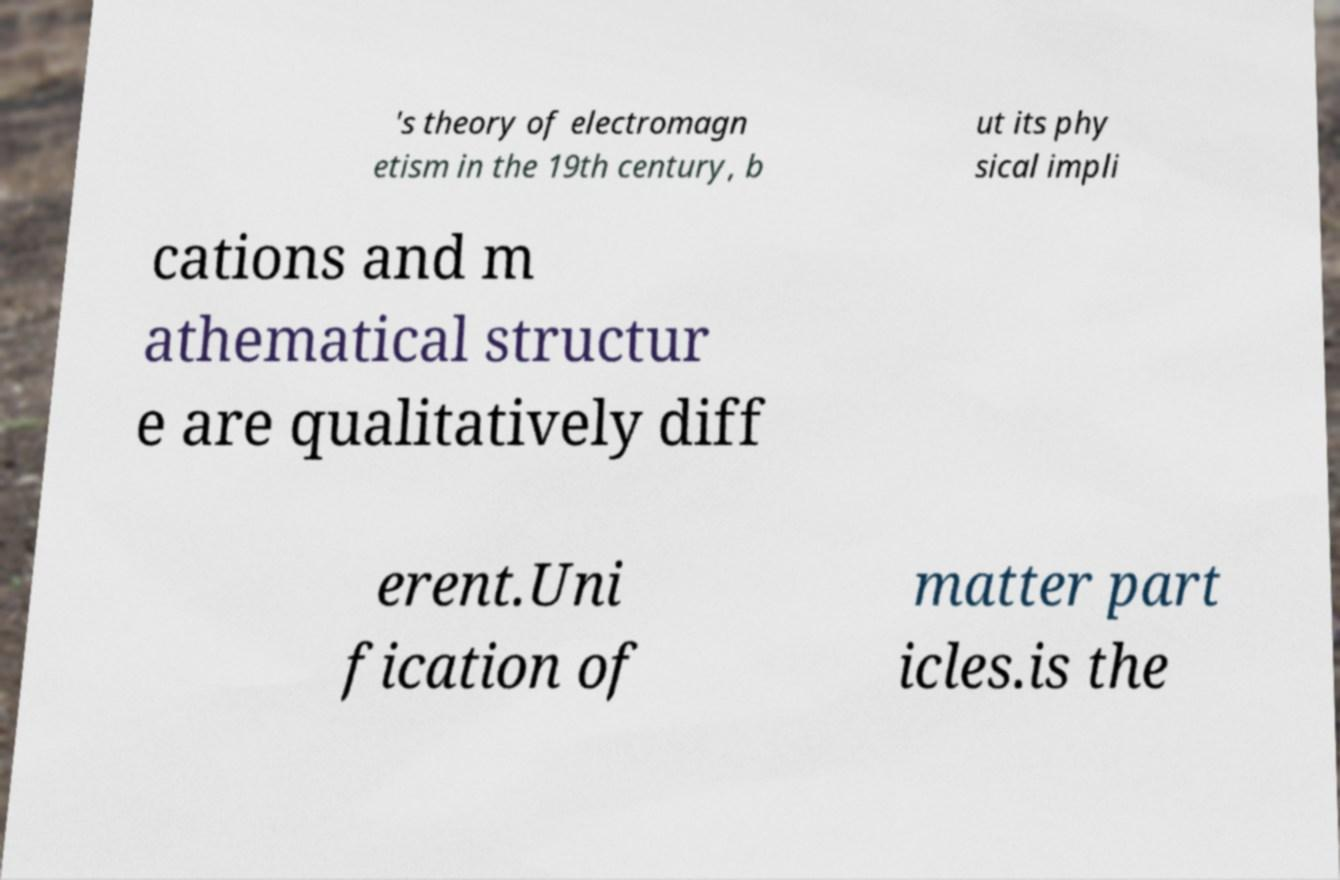Could you extract and type out the text from this image? 's theory of electromagn etism in the 19th century, b ut its phy sical impli cations and m athematical structur e are qualitatively diff erent.Uni fication of matter part icles.is the 